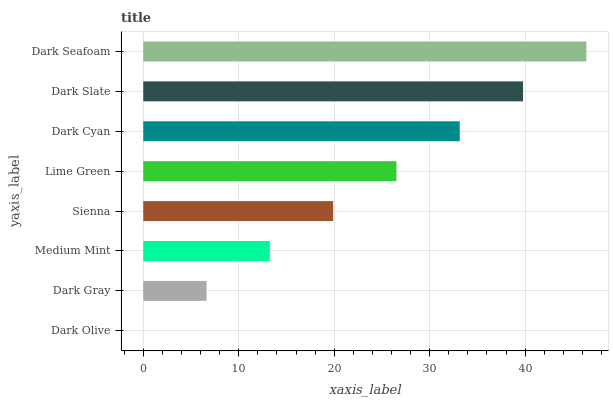Is Dark Olive the minimum?
Answer yes or no. Yes. Is Dark Seafoam the maximum?
Answer yes or no. Yes. Is Dark Gray the minimum?
Answer yes or no. No. Is Dark Gray the maximum?
Answer yes or no. No. Is Dark Gray greater than Dark Olive?
Answer yes or no. Yes. Is Dark Olive less than Dark Gray?
Answer yes or no. Yes. Is Dark Olive greater than Dark Gray?
Answer yes or no. No. Is Dark Gray less than Dark Olive?
Answer yes or no. No. Is Lime Green the high median?
Answer yes or no. Yes. Is Sienna the low median?
Answer yes or no. Yes. Is Dark Slate the high median?
Answer yes or no. No. Is Medium Mint the low median?
Answer yes or no. No. 